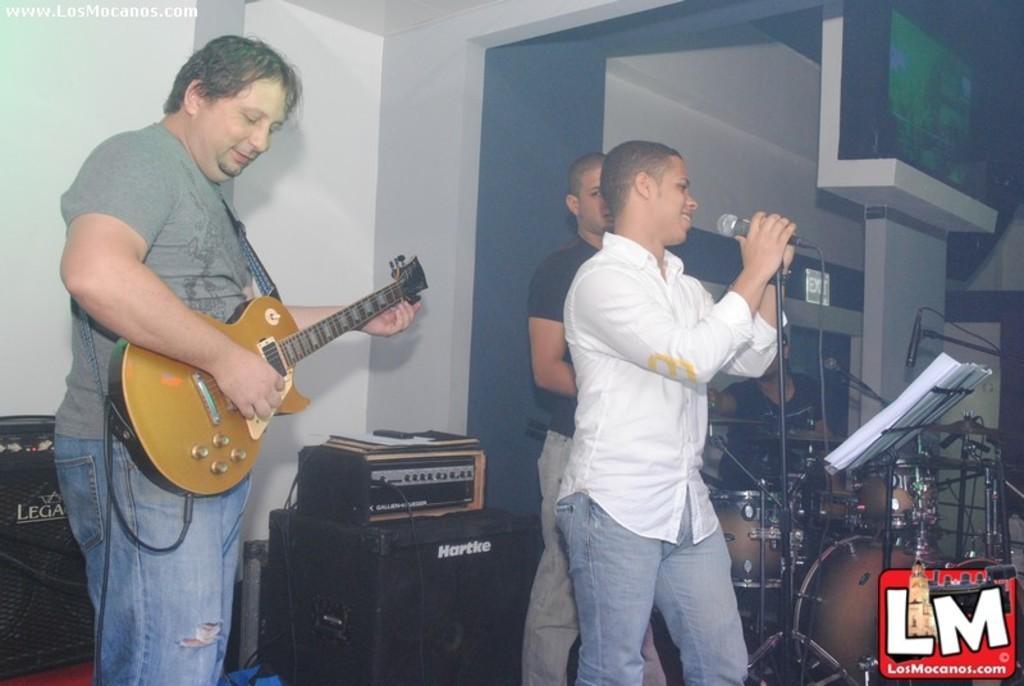Please provide a concise description of this image. The picture consists of a guy playing a guitar and in front of him there is another guy with white shirt singing on mic and backside there a guy playing guitar and its all seems to be a band. there are many music equipments near the wall. 